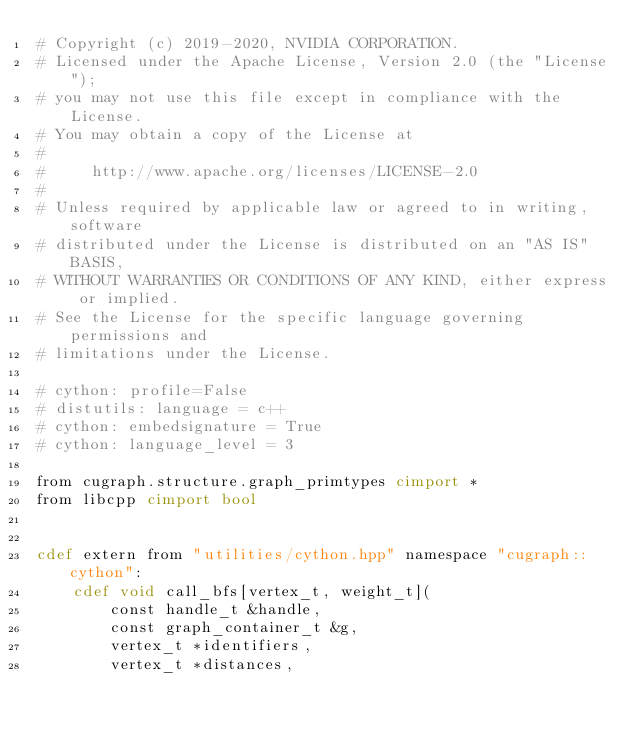Convert code to text. <code><loc_0><loc_0><loc_500><loc_500><_Cython_># Copyright (c) 2019-2020, NVIDIA CORPORATION.
# Licensed under the Apache License, Version 2.0 (the "License");
# you may not use this file except in compliance with the License.
# You may obtain a copy of the License at
#
#     http://www.apache.org/licenses/LICENSE-2.0
#
# Unless required by applicable law or agreed to in writing, software
# distributed under the License is distributed on an "AS IS" BASIS,
# WITHOUT WARRANTIES OR CONDITIONS OF ANY KIND, either express or implied.
# See the License for the specific language governing permissions and
# limitations under the License.

# cython: profile=False
# distutils: language = c++
# cython: embedsignature = True
# cython: language_level = 3

from cugraph.structure.graph_primtypes cimport *
from libcpp cimport bool


cdef extern from "utilities/cython.hpp" namespace "cugraph::cython":
    cdef void call_bfs[vertex_t, weight_t](
        const handle_t &handle,
        const graph_container_t &g,
        vertex_t *identifiers,
        vertex_t *distances,</code> 